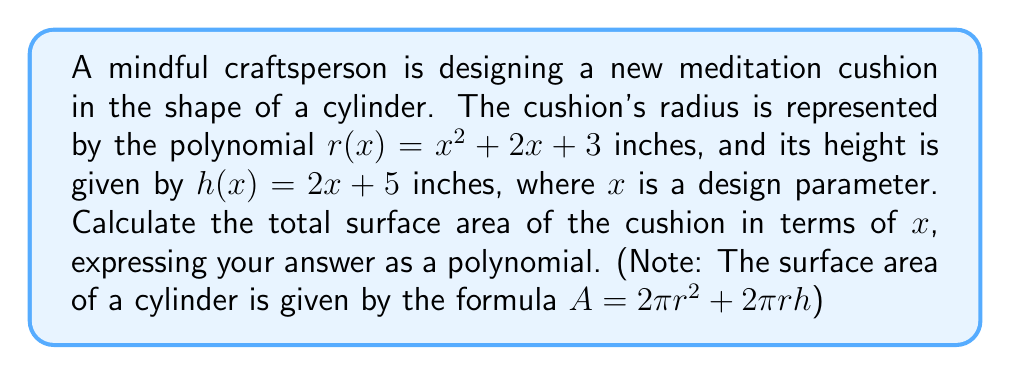Teach me how to tackle this problem. Let's approach this step-by-step:

1) We're given that $r(x) = x^2 + 2x + 3$ and $h(x) = 2x + 5$

2) The formula for the surface area of a cylinder is $A = 2\pi r^2 + 2\pi rh$

3) Let's calculate $r^2$ first:
   $r^2 = (x^2 + 2x + 3)^2 = x^4 + 4x^3 + 10x^2 + 12x + 9$

4) Now, let's calculate $rh$:
   $rh = (x^2 + 2x + 3)(2x + 5) = 2x^3 + 5x^2 + 4x^2 + 10x + 6x + 15 = 2x^3 + 9x^2 + 16x + 15$

5) Now we can substitute these into our surface area formula:
   $A = 2\pi(x^4 + 4x^3 + 10x^2 + 12x + 9) + 2\pi(2x^3 + 9x^2 + 16x + 15)$

6) Combining like terms:
   $A = 2\pi(x^4 + 6x^3 + 19x^2 + 28x + 24)$

7) Simplifying:
   $A = 2\pi x^4 + 12\pi x^3 + 38\pi x^2 + 56\pi x + 48\pi$

This polynomial represents the total surface area of the meditation cushion in terms of $x$.
Answer: $A = 2\pi x^4 + 12\pi x^3 + 38\pi x^2 + 56\pi x + 48\pi$ square inches 